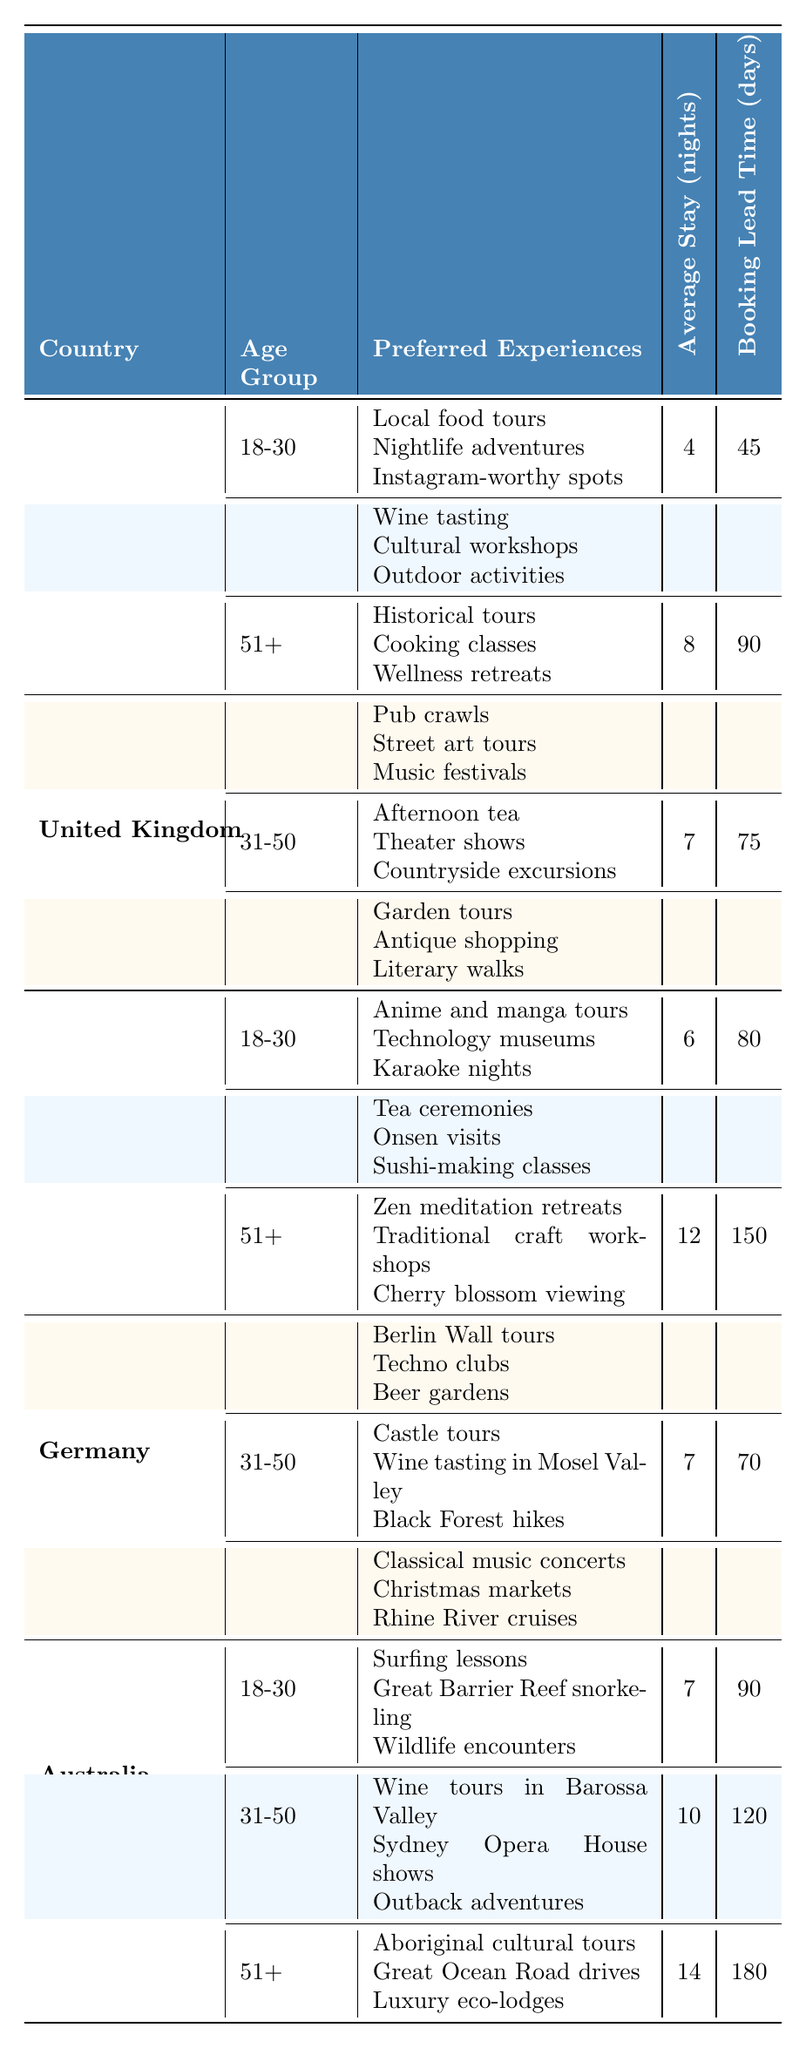What is the average stay for guests from Japan aged 31-50? Looking at the table under Japan and the age group 31-50, the average stay is listed as 8 nights.
Answer: 8 nights Which country has the highest average stay for guests aged 51 and older? Comparing the average stays for each country in the 51+ age group, Australia has the highest average stay of 14 nights.
Answer: Australia Do guests from the United States who are aged 18-30 prefer historical tours? The preferred experiences for guests from the United States aged 18-30 include local food tours, nightlife adventures, and Instagram-worthy spots, but do not include historical tours.
Answer: No What are the total nights stayed for guests aged 31-50 from Germany? The average stay for this age group in Germany is 7 nights, and since there are 3 entries for each age group, we multiply 7 by 3 (7 + 7 + 7) = 21 nights.
Answer: 21 nights How much lead time, on average, do guests from the United Kingdom in the 51+ age group need for booking? Looking at the United Kingdom and the 51+ age group, the booking lead time is listed as 120 days.
Answer: 120 days Which age group prefers pub crawls in the United Kingdom? The table shows that the preferred experiences for guests from the United Kingdom in the 18-30 age group include pub crawls.
Answer: 18-30 If you were to compare the booking lead times of guests aged 18-30 from Japan and Germany, which country has a longer lead time? The booking lead time for Japan (18-30) is 80 days, while for Germany it is 40 days. Therefore, Japan has a longer lead time.
Answer: Japan What is the difference in average stay between guests aged 51+ from Australia and Germany? The average stay for guests aged 51+ from Australia is 14 nights, and from Germany, it is 9 nights. The difference is 14 - 9 = 5 nights.
Answer: 5 nights Are there more preferred experiences listed for guests aged 31-50 from the United Kingdom than those from Germany? Both age groups have three preferred experiences listed in the table: United Kingdom (31-50) has three, and Germany (31-50) also has three, so they have the same number.
Answer: No What is the average booking lead time for all countries for guests aged 18-30? The given booking lead times for the 18-30 age group are: United States (45 days), United Kingdom (50 days), Japan (80 days), Germany (40 days), and Australia (90 days). The average is calculated as (45 + 50 + 80 + 40 + 90) / 5 = 61 days.
Answer: 61 days 